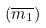<formula> <loc_0><loc_0><loc_500><loc_500>( \overline { m _ { 1 } } )</formula> 